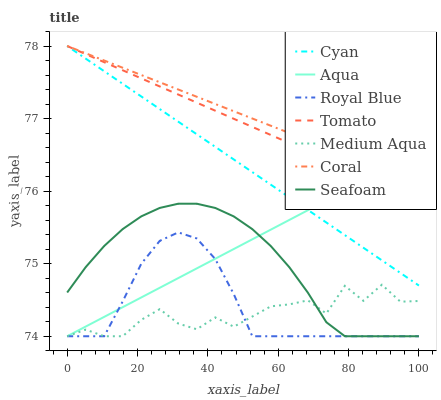Does Medium Aqua have the minimum area under the curve?
Answer yes or no. Yes. Does Coral have the maximum area under the curve?
Answer yes or no. Yes. Does Aqua have the minimum area under the curve?
Answer yes or no. No. Does Aqua have the maximum area under the curve?
Answer yes or no. No. Is Coral the smoothest?
Answer yes or no. Yes. Is Medium Aqua the roughest?
Answer yes or no. Yes. Is Aqua the smoothest?
Answer yes or no. No. Is Aqua the roughest?
Answer yes or no. No. Does Aqua have the lowest value?
Answer yes or no. Yes. Does Coral have the lowest value?
Answer yes or no. No. Does Cyan have the highest value?
Answer yes or no. Yes. Does Aqua have the highest value?
Answer yes or no. No. Is Seafoam less than Coral?
Answer yes or no. Yes. Is Cyan greater than Seafoam?
Answer yes or no. Yes. Does Aqua intersect Medium Aqua?
Answer yes or no. Yes. Is Aqua less than Medium Aqua?
Answer yes or no. No. Is Aqua greater than Medium Aqua?
Answer yes or no. No. Does Seafoam intersect Coral?
Answer yes or no. No. 